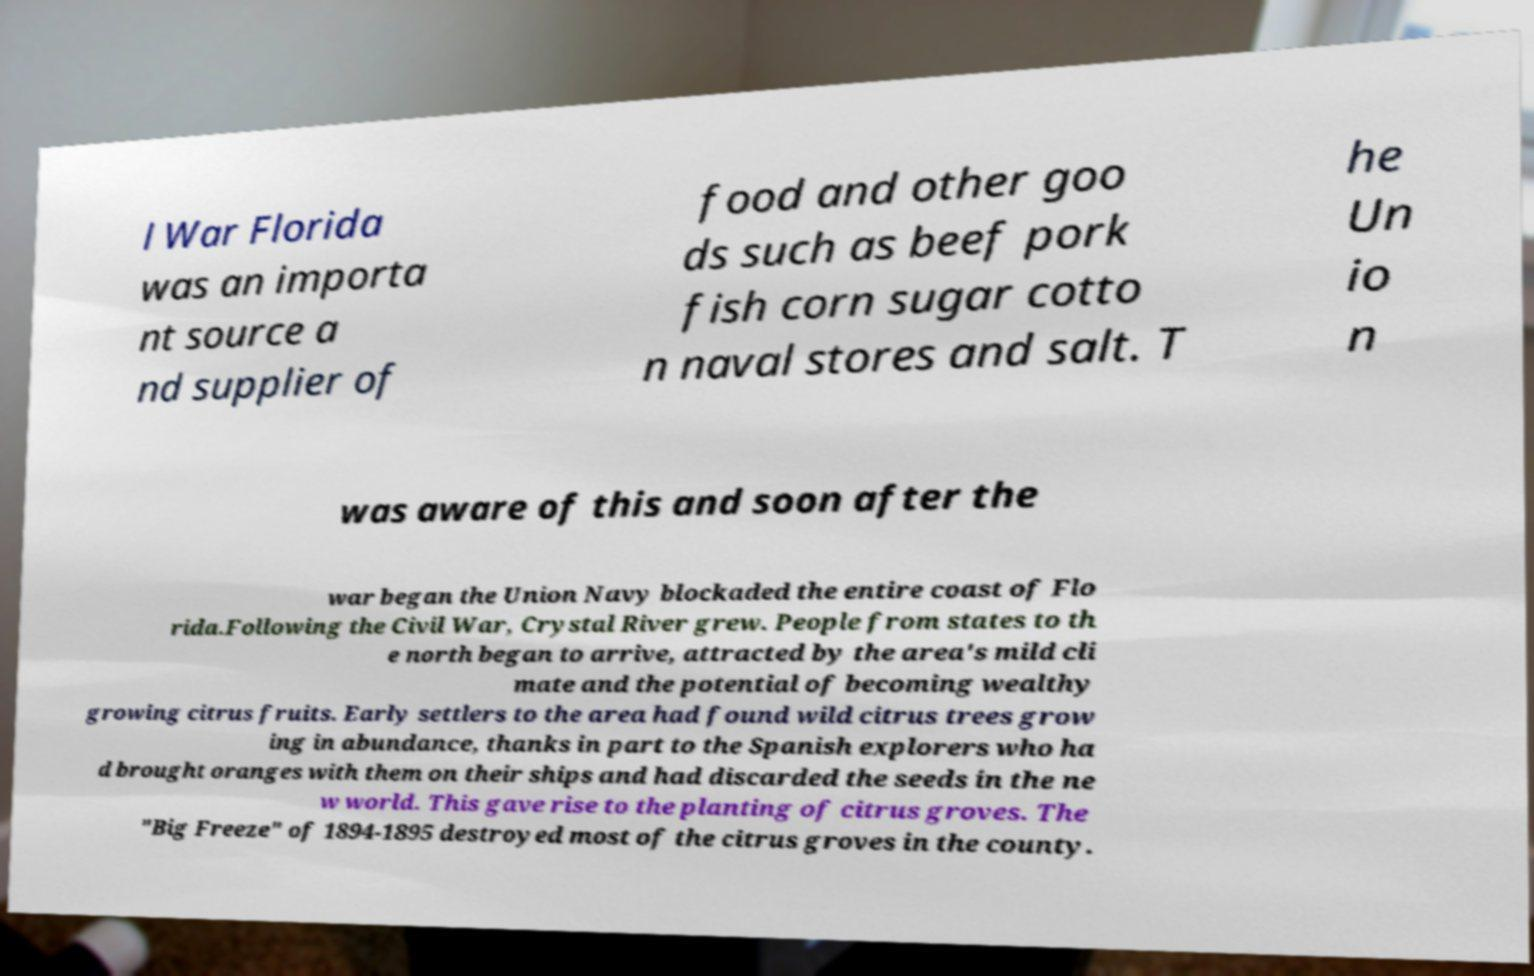For documentation purposes, I need the text within this image transcribed. Could you provide that? l War Florida was an importa nt source a nd supplier of food and other goo ds such as beef pork fish corn sugar cotto n naval stores and salt. T he Un io n was aware of this and soon after the war began the Union Navy blockaded the entire coast of Flo rida.Following the Civil War, Crystal River grew. People from states to th e north began to arrive, attracted by the area's mild cli mate and the potential of becoming wealthy growing citrus fruits. Early settlers to the area had found wild citrus trees grow ing in abundance, thanks in part to the Spanish explorers who ha d brought oranges with them on their ships and had discarded the seeds in the ne w world. This gave rise to the planting of citrus groves. The "Big Freeze" of 1894-1895 destroyed most of the citrus groves in the county. 